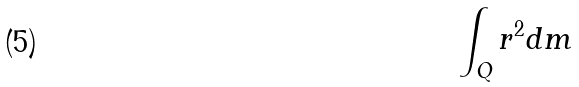Convert formula to latex. <formula><loc_0><loc_0><loc_500><loc_500>\int _ { Q } r ^ { 2 } d m</formula> 